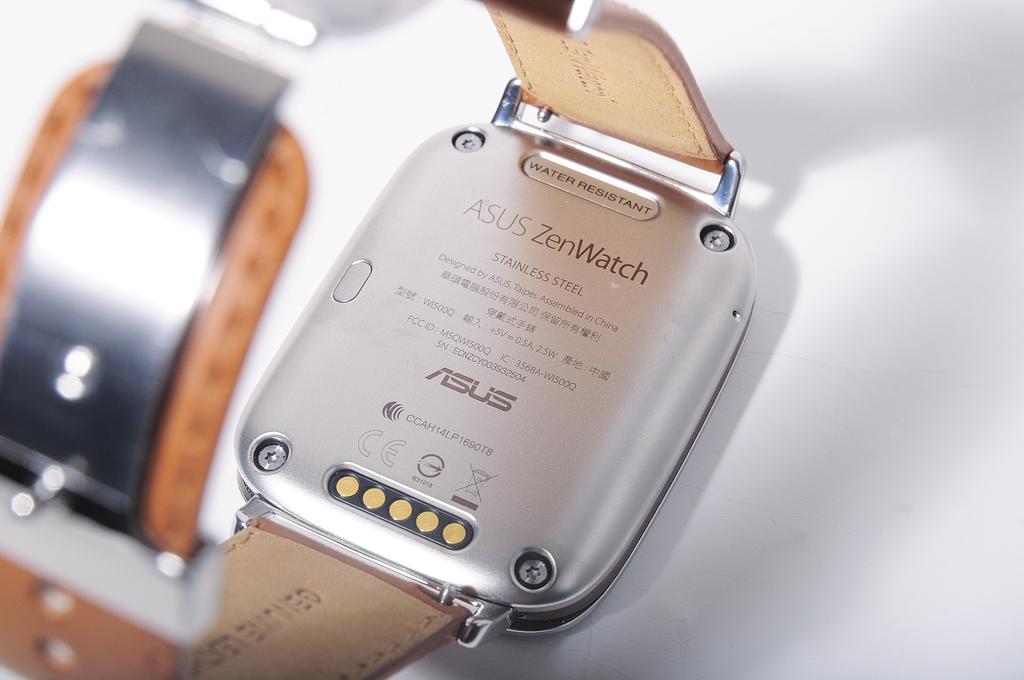What is the brand of watch schown here?
Provide a short and direct response. Asus. 